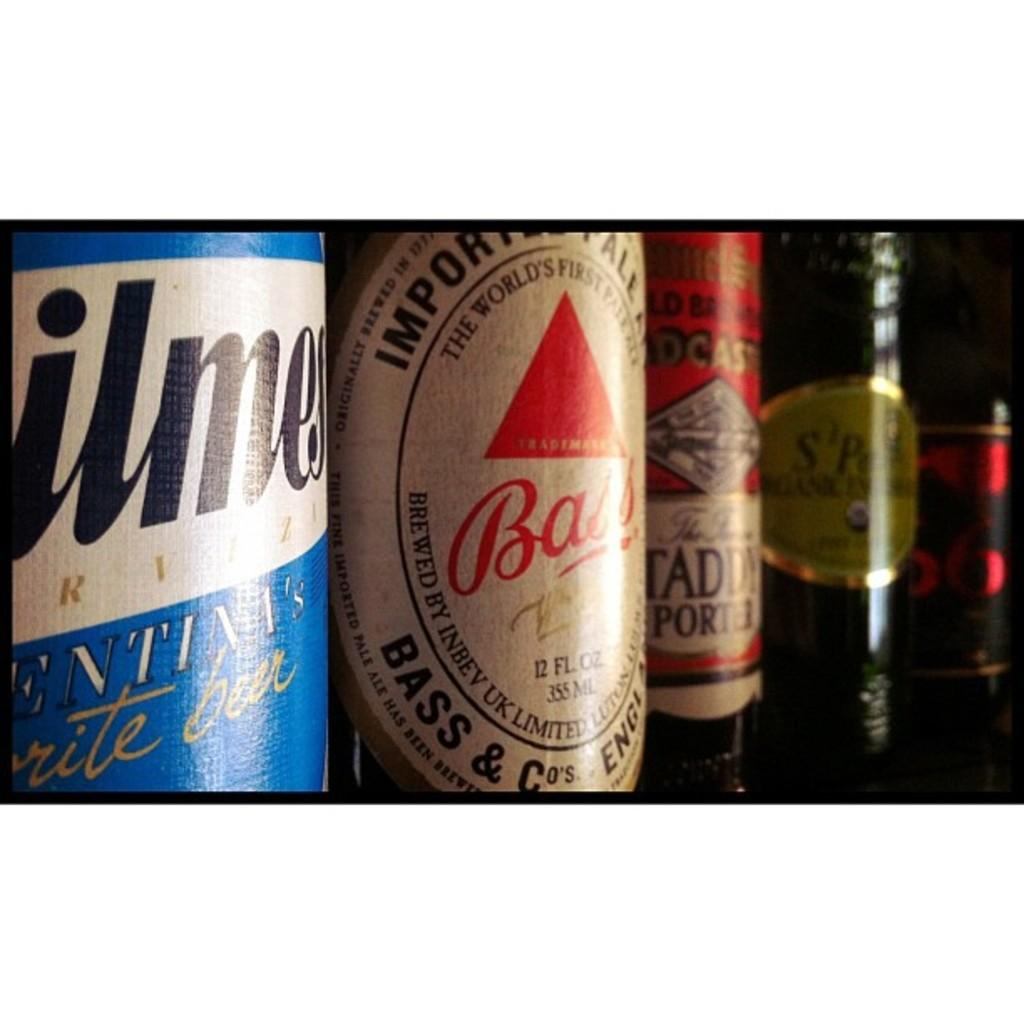Provide a one-sentence caption for the provided image. A bottle of Bass beer stands alongside some other beers. 